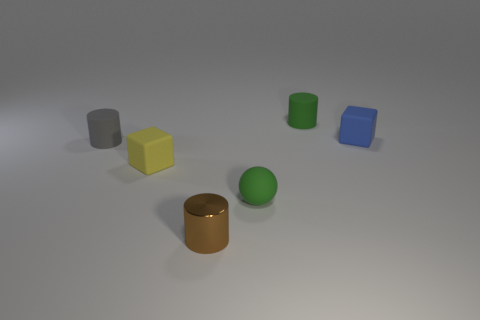Is there anything else that is made of the same material as the tiny brown thing?
Make the answer very short. No. Is the number of blue rubber objects less than the number of cyan shiny objects?
Offer a terse response. No. There is a green object that is behind the small rubber cylinder that is to the left of the matte cylinder to the right of the gray thing; what is its shape?
Offer a very short reply. Cylinder. There is a small rubber thing that is the same color as the small rubber sphere; what shape is it?
Offer a very short reply. Cylinder. Are any tiny gray cubes visible?
Provide a succinct answer. No. There is a metallic thing; is it the same size as the rubber block that is on the left side of the small blue object?
Provide a succinct answer. Yes. There is a tiny rubber cylinder that is right of the tiny shiny object; is there a tiny green rubber cylinder that is on the left side of it?
Your answer should be compact. No. The cylinder that is both on the right side of the small yellow rubber cube and in front of the blue object is made of what material?
Provide a succinct answer. Metal. What is the color of the rubber cylinder that is in front of the cylinder behind the small rubber cylinder that is in front of the blue matte block?
Provide a succinct answer. Gray. There is a rubber cube that is the same size as the blue object; what is its color?
Provide a short and direct response. Yellow. 